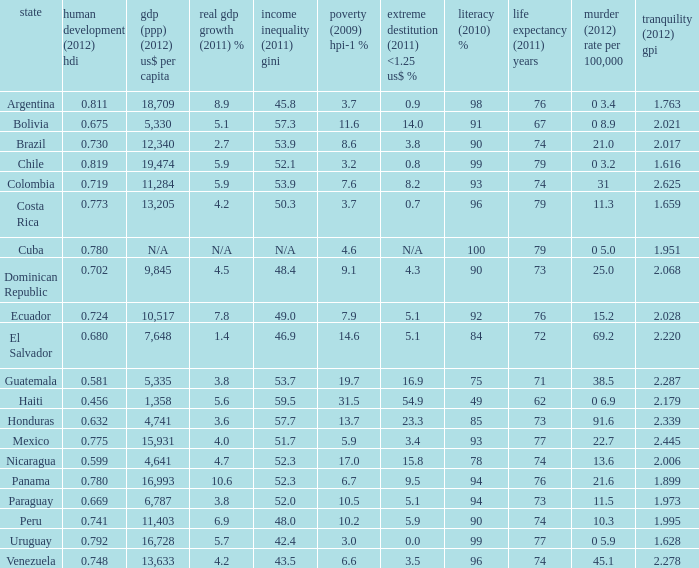What is the total poverty (2009) HPI-1 % when the extreme poverty (2011) <1.25 US$ % of 16.9, and the human development (2012) HDI is less than 0.581? None. 